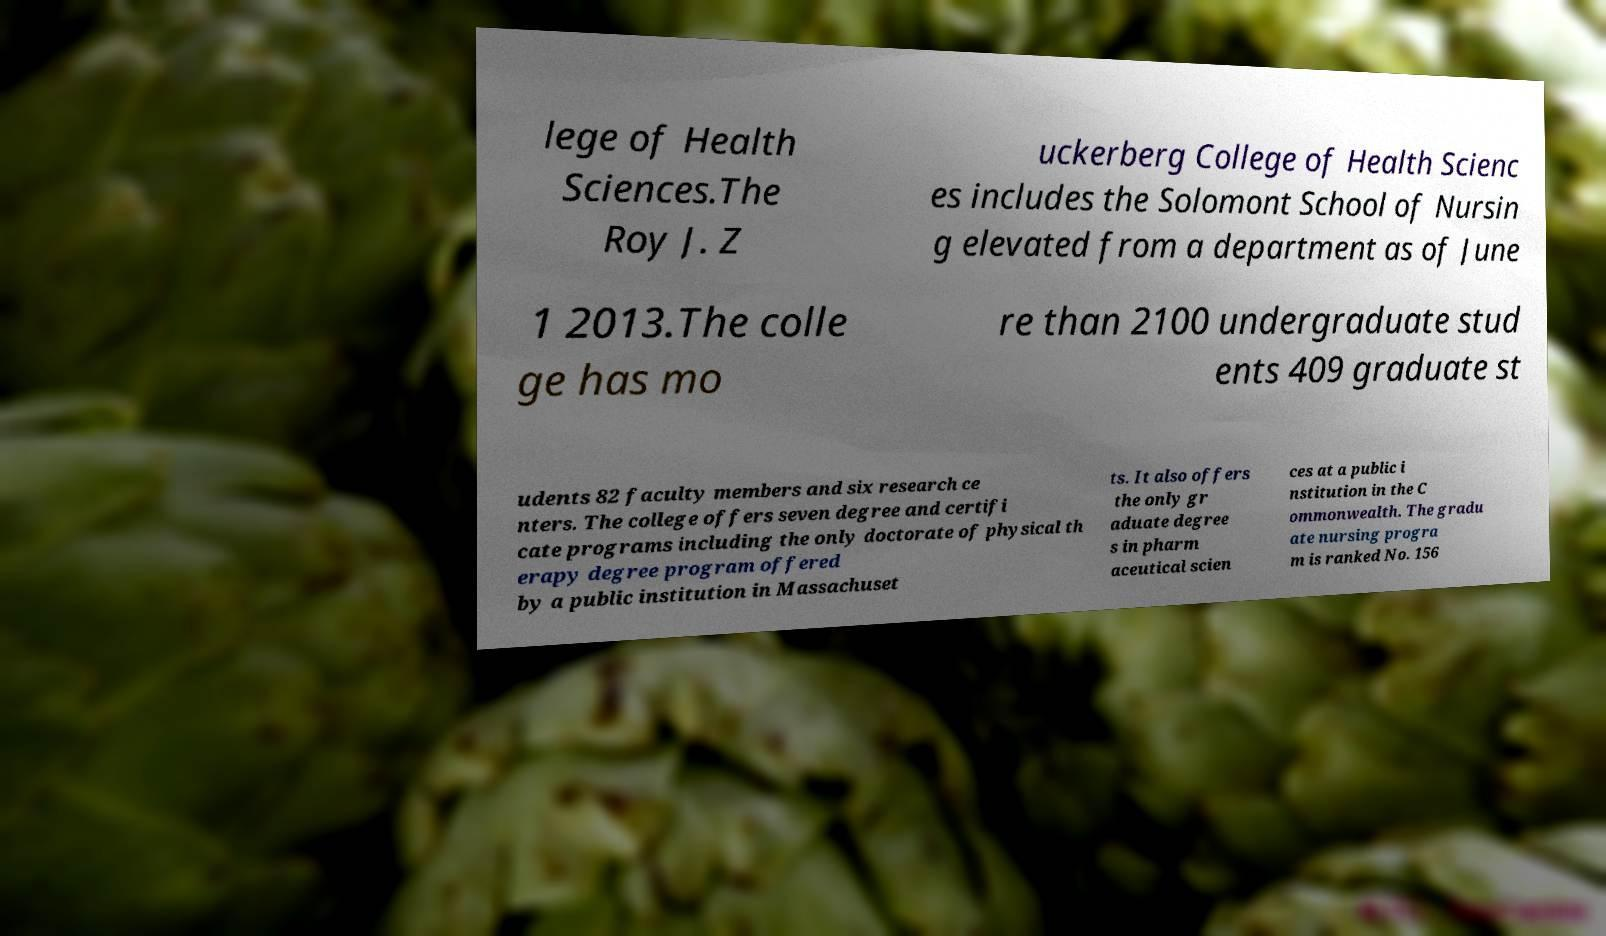Please read and relay the text visible in this image. What does it say? lege of Health Sciences.The Roy J. Z uckerberg College of Health Scienc es includes the Solomont School of Nursin g elevated from a department as of June 1 2013.The colle ge has mo re than 2100 undergraduate stud ents 409 graduate st udents 82 faculty members and six research ce nters. The college offers seven degree and certifi cate programs including the only doctorate of physical th erapy degree program offered by a public institution in Massachuset ts. It also offers the only gr aduate degree s in pharm aceutical scien ces at a public i nstitution in the C ommonwealth. The gradu ate nursing progra m is ranked No. 156 